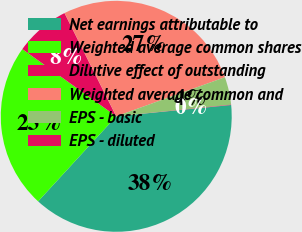Convert chart. <chart><loc_0><loc_0><loc_500><loc_500><pie_chart><fcel>Net earnings attributable to<fcel>Weighted average common shares<fcel>Dilutive effect of outstanding<fcel>Weighted average common and<fcel>EPS - basic<fcel>EPS - diluted<nl><fcel>38.39%<fcel>23.06%<fcel>7.72%<fcel>26.9%<fcel>3.88%<fcel>0.05%<nl></chart> 